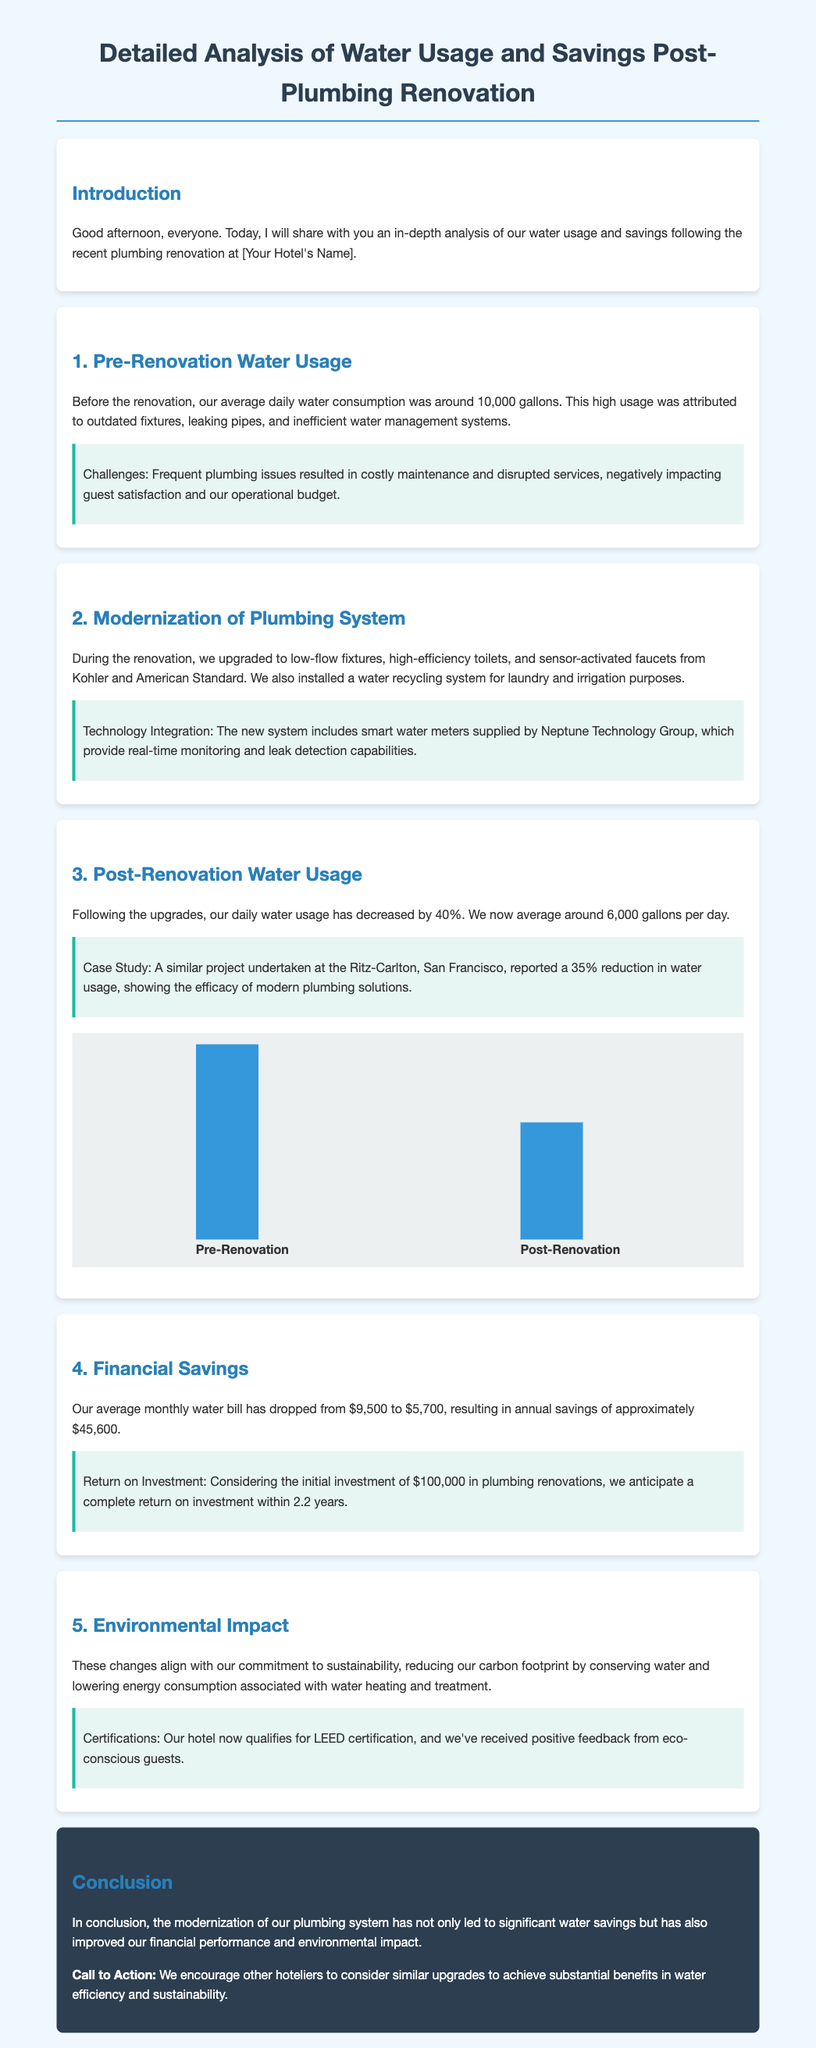What was the average daily water consumption before the renovation? The average daily water consumption before the renovation was around 10,000 gallons.
Answer: 10,000 gallons What is the reduction in daily water usage after the renovation? The document states that daily water usage decreased by 40%.
Answer: 40% What is the average monthly water bill post-renovation? The average monthly water bill post-renovation is $5,700.
Answer: $5,700 How much annual savings was achieved after the renovation? The document lists annual savings of approximately $45,600.
Answer: $45,600 What was the initial investment in plumbing renovations? The initial investment mentioned in the document was $100,000.
Answer: $100,000 Which brands were used for the low-flow fixtures and toilets? The brands used for the low-flow fixtures and toilets were Kohler and American Standard.
Answer: Kohler and American Standard What certification does the hotel now qualify for? The hotel now qualifies for LEED certification.
Answer: LEED certification What was the average daily water consumption after the renovation? The average daily water consumption after the renovation is around 6,000 gallons.
Answer: 6,000 gallons What is the expected return on investment time frame? The expected return on investment time frame is within 2.2 years.
Answer: 2.2 years 